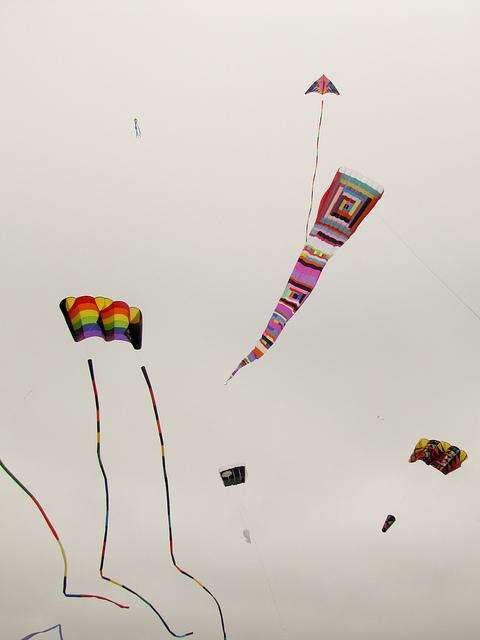What is rising in the air? kites 